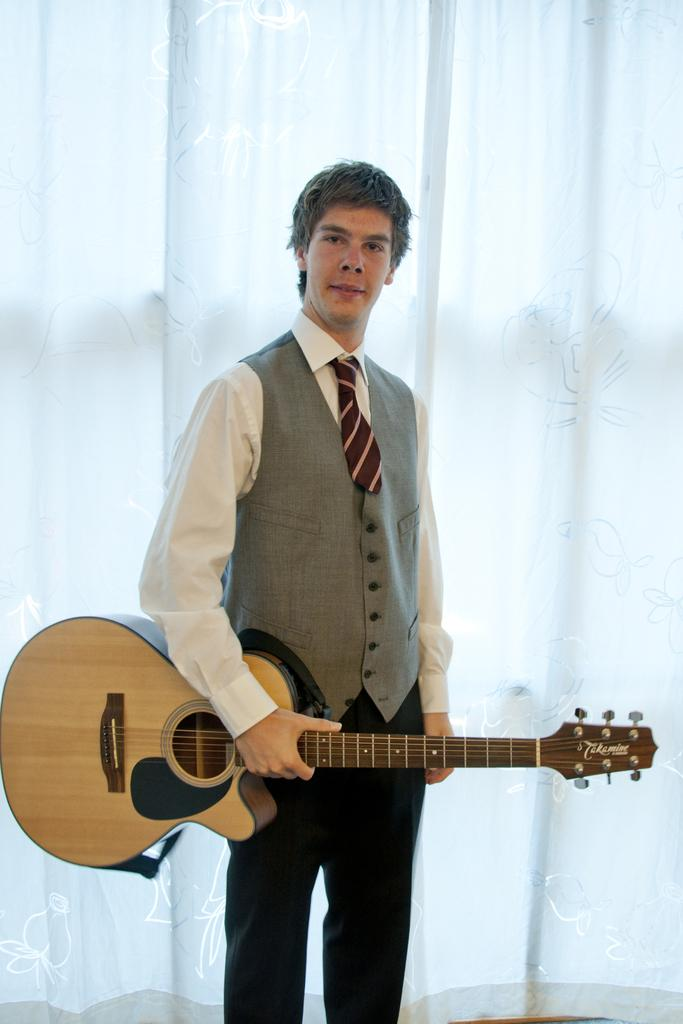Who is present in the image? There is a man in the image. What is the man doing in the image? The man is standing in the image. What is the man holding in the image? The man is holding a yellow-colored music instrument in the image. What can be seen in the background of the image? There is a white-colored curtain in the background of the image. How many mice are visible on the man's shoulder in the image? There are no mice visible on the man's shoulder in the image. 